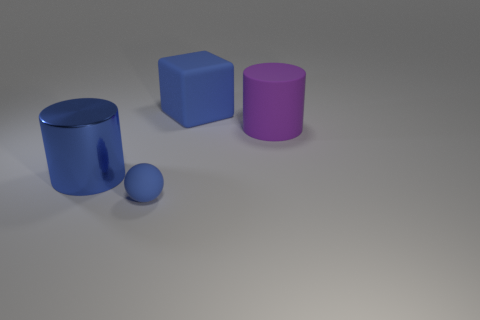There is a rubber cube that is the same color as the tiny sphere; what size is it?
Offer a very short reply. Large. Is the large metallic thing the same color as the small matte sphere?
Provide a short and direct response. Yes. What is the material of the blue object behind the blue metallic cylinder?
Offer a terse response. Rubber. What number of tiny things are purple rubber things or matte spheres?
Ensure brevity in your answer.  1. What is the material of the cube that is the same color as the tiny thing?
Your answer should be compact. Rubber. Are there any big cylinders that have the same material as the large block?
Offer a very short reply. Yes. Is the size of the cylinder behind the blue cylinder the same as the metal cylinder?
Ensure brevity in your answer.  Yes. There is a blue cylinder that is to the left of the blue object that is behind the purple cylinder; are there any things behind it?
Offer a terse response. Yes. How many shiny objects are green blocks or small things?
Your answer should be very brief. 0. What number of other things are the same shape as the big blue matte object?
Make the answer very short. 0. 